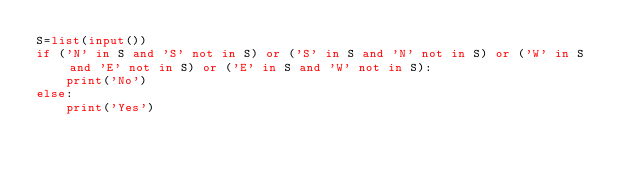<code> <loc_0><loc_0><loc_500><loc_500><_Python_>S=list(input())
if ('N' in S and 'S' not in S) or ('S' in S and 'N' not in S) or ('W' in S and 'E' not in S) or ('E' in S and 'W' not in S):
    print('No') 
else:
    print('Yes')</code> 